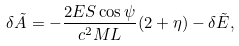Convert formula to latex. <formula><loc_0><loc_0><loc_500><loc_500>\delta \tilde { A } = - \frac { 2 E S \cos \psi } { c ^ { 2 } M L } ( 2 + \eta ) - \delta \tilde { E } ,</formula> 